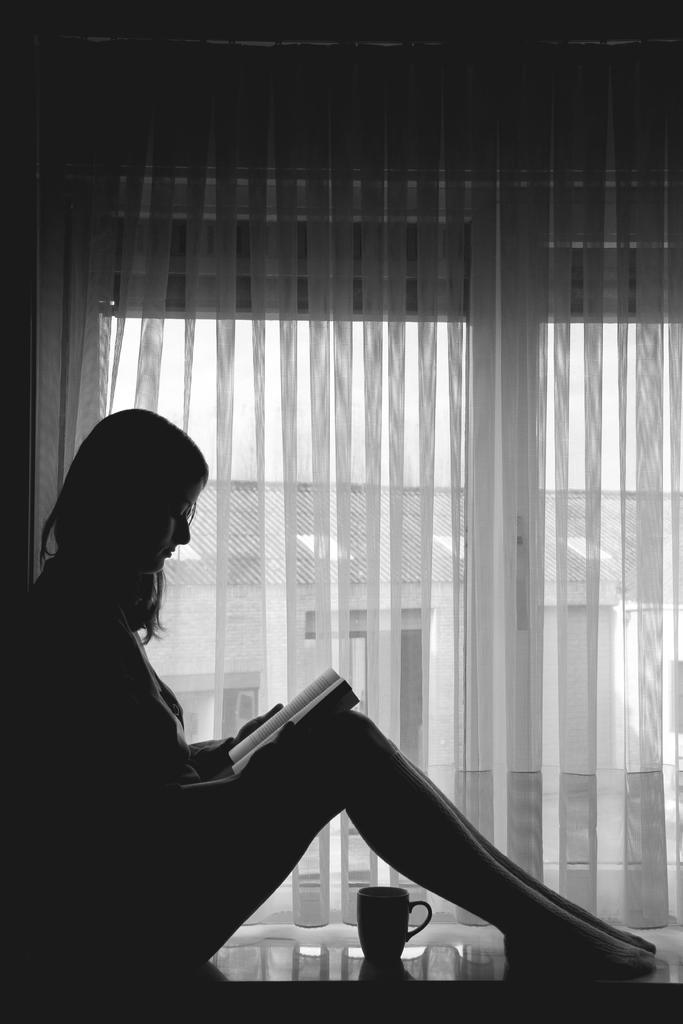Please provide a concise description of this image. There is a woman sitting and holding a book and we can see cup on the platform, beside her we can see curtains, through these curtains we can see building and sky. 